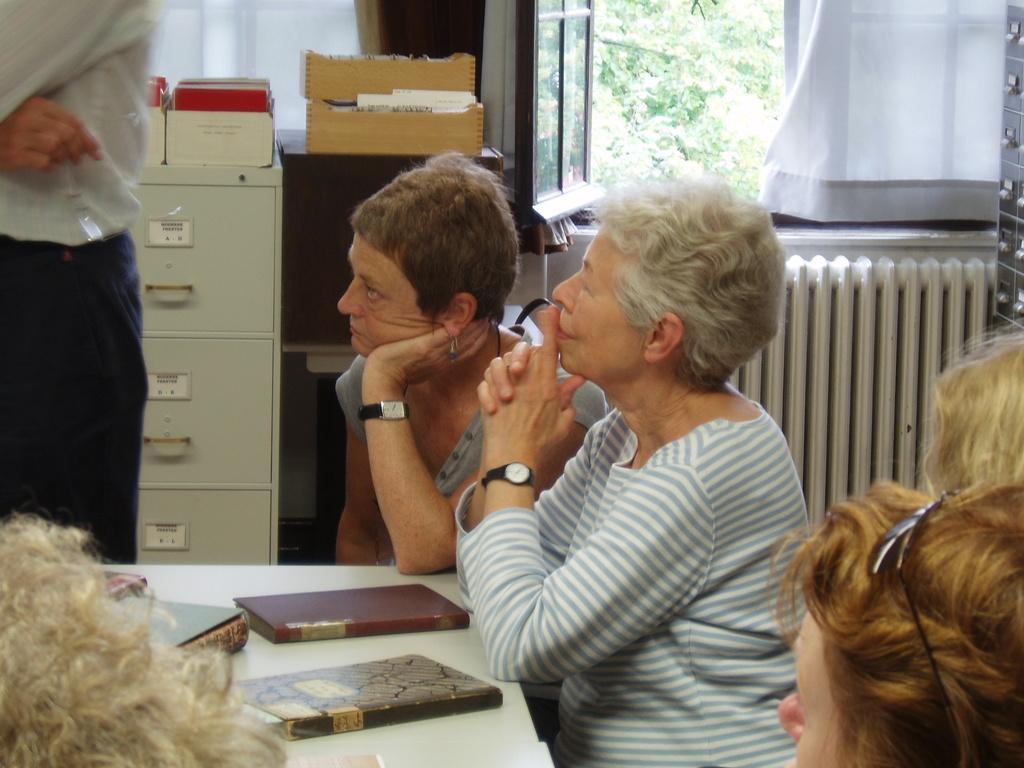How would you summarize this image in a sentence or two? In the foreground of this image, there are head of the persons and in the background, there are two women sitting near a table on which books are placed and also there is a man standing, few lockers, boxes, windows, curtains and through the window there are trees. 